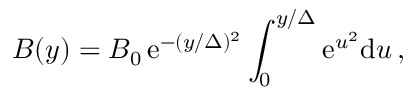Convert formula to latex. <formula><loc_0><loc_0><loc_500><loc_500>B ( y ) = B _ { 0 } \, e ^ { - ( y / \Delta ) ^ { 2 } } \int _ { 0 } ^ { y / \Delta } e ^ { u ^ { 2 } } d u \, ,</formula> 